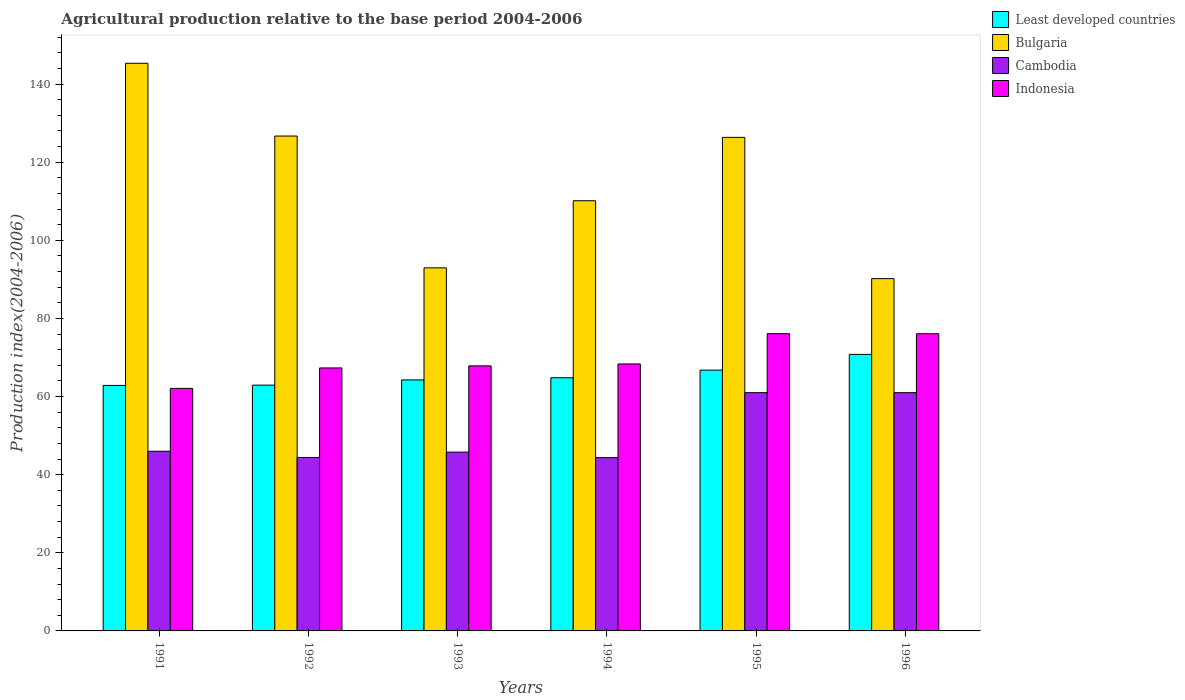How many groups of bars are there?
Provide a short and direct response. 6. Are the number of bars per tick equal to the number of legend labels?
Provide a short and direct response. Yes. Are the number of bars on each tick of the X-axis equal?
Your answer should be compact. Yes. How many bars are there on the 1st tick from the right?
Offer a terse response. 4. What is the label of the 6th group of bars from the left?
Your answer should be compact. 1996. In how many cases, is the number of bars for a given year not equal to the number of legend labels?
Ensure brevity in your answer.  0. What is the agricultural production index in Cambodia in 1995?
Your response must be concise. 60.99. Across all years, what is the maximum agricultural production index in Least developed countries?
Provide a succinct answer. 70.79. Across all years, what is the minimum agricultural production index in Least developed countries?
Your answer should be compact. 62.84. What is the total agricultural production index in Least developed countries in the graph?
Make the answer very short. 392.36. What is the difference between the agricultural production index in Cambodia in 1991 and that in 1993?
Provide a succinct answer. 0.23. What is the difference between the agricultural production index in Least developed countries in 1992 and the agricultural production index in Bulgaria in 1991?
Keep it short and to the point. -82.39. What is the average agricultural production index in Cambodia per year?
Provide a short and direct response. 50.42. In the year 1991, what is the difference between the agricultural production index in Cambodia and agricultural production index in Indonesia?
Ensure brevity in your answer.  -16.08. What is the ratio of the agricultural production index in Bulgaria in 1993 to that in 1996?
Provide a short and direct response. 1.03. Is the difference between the agricultural production index in Cambodia in 1992 and 1993 greater than the difference between the agricultural production index in Indonesia in 1992 and 1993?
Your answer should be very brief. No. What is the difference between the highest and the second highest agricultural production index in Indonesia?
Offer a very short reply. 0.02. What is the difference between the highest and the lowest agricultural production index in Cambodia?
Give a very brief answer. 16.63. Is the sum of the agricultural production index in Cambodia in 1993 and 1994 greater than the maximum agricultural production index in Bulgaria across all years?
Give a very brief answer. No. What does the 2nd bar from the left in 1996 represents?
Provide a succinct answer. Bulgaria. What does the 2nd bar from the right in 1996 represents?
Provide a short and direct response. Cambodia. How many bars are there?
Your response must be concise. 24. How many years are there in the graph?
Provide a short and direct response. 6. What is the difference between two consecutive major ticks on the Y-axis?
Make the answer very short. 20. Are the values on the major ticks of Y-axis written in scientific E-notation?
Your response must be concise. No. Does the graph contain any zero values?
Offer a very short reply. No. Does the graph contain grids?
Make the answer very short. No. How many legend labels are there?
Your response must be concise. 4. What is the title of the graph?
Keep it short and to the point. Agricultural production relative to the base period 2004-2006. What is the label or title of the Y-axis?
Provide a short and direct response. Production index(2004-2006). What is the Production index(2004-2006) of Least developed countries in 1991?
Offer a very short reply. 62.84. What is the Production index(2004-2006) in Bulgaria in 1991?
Provide a succinct answer. 145.31. What is the Production index(2004-2006) in Indonesia in 1991?
Offer a very short reply. 62.08. What is the Production index(2004-2006) in Least developed countries in 1992?
Your answer should be compact. 62.92. What is the Production index(2004-2006) in Bulgaria in 1992?
Provide a succinct answer. 126.68. What is the Production index(2004-2006) in Cambodia in 1992?
Your response must be concise. 44.4. What is the Production index(2004-2006) of Indonesia in 1992?
Ensure brevity in your answer.  67.32. What is the Production index(2004-2006) of Least developed countries in 1993?
Offer a very short reply. 64.25. What is the Production index(2004-2006) of Bulgaria in 1993?
Provide a short and direct response. 92.94. What is the Production index(2004-2006) in Cambodia in 1993?
Offer a terse response. 45.77. What is the Production index(2004-2006) of Indonesia in 1993?
Ensure brevity in your answer.  67.85. What is the Production index(2004-2006) of Least developed countries in 1994?
Your answer should be very brief. 64.8. What is the Production index(2004-2006) in Bulgaria in 1994?
Your answer should be compact. 110.12. What is the Production index(2004-2006) of Cambodia in 1994?
Ensure brevity in your answer.  44.36. What is the Production index(2004-2006) in Indonesia in 1994?
Keep it short and to the point. 68.34. What is the Production index(2004-2006) of Least developed countries in 1995?
Provide a short and direct response. 66.75. What is the Production index(2004-2006) in Bulgaria in 1995?
Make the answer very short. 126.34. What is the Production index(2004-2006) in Cambodia in 1995?
Your answer should be compact. 60.99. What is the Production index(2004-2006) of Indonesia in 1995?
Offer a terse response. 76.09. What is the Production index(2004-2006) in Least developed countries in 1996?
Keep it short and to the point. 70.79. What is the Production index(2004-2006) of Bulgaria in 1996?
Offer a very short reply. 90.18. What is the Production index(2004-2006) in Cambodia in 1996?
Your answer should be very brief. 60.99. What is the Production index(2004-2006) in Indonesia in 1996?
Make the answer very short. 76.07. Across all years, what is the maximum Production index(2004-2006) of Least developed countries?
Provide a short and direct response. 70.79. Across all years, what is the maximum Production index(2004-2006) in Bulgaria?
Your answer should be compact. 145.31. Across all years, what is the maximum Production index(2004-2006) in Cambodia?
Make the answer very short. 60.99. Across all years, what is the maximum Production index(2004-2006) of Indonesia?
Give a very brief answer. 76.09. Across all years, what is the minimum Production index(2004-2006) of Least developed countries?
Keep it short and to the point. 62.84. Across all years, what is the minimum Production index(2004-2006) of Bulgaria?
Offer a very short reply. 90.18. Across all years, what is the minimum Production index(2004-2006) in Cambodia?
Your response must be concise. 44.36. Across all years, what is the minimum Production index(2004-2006) of Indonesia?
Provide a succinct answer. 62.08. What is the total Production index(2004-2006) of Least developed countries in the graph?
Offer a very short reply. 392.36. What is the total Production index(2004-2006) in Bulgaria in the graph?
Offer a very short reply. 691.57. What is the total Production index(2004-2006) in Cambodia in the graph?
Ensure brevity in your answer.  302.51. What is the total Production index(2004-2006) in Indonesia in the graph?
Ensure brevity in your answer.  417.75. What is the difference between the Production index(2004-2006) in Least developed countries in 1991 and that in 1992?
Offer a terse response. -0.07. What is the difference between the Production index(2004-2006) in Bulgaria in 1991 and that in 1992?
Offer a very short reply. 18.63. What is the difference between the Production index(2004-2006) of Indonesia in 1991 and that in 1992?
Your response must be concise. -5.24. What is the difference between the Production index(2004-2006) of Least developed countries in 1991 and that in 1993?
Ensure brevity in your answer.  -1.41. What is the difference between the Production index(2004-2006) of Bulgaria in 1991 and that in 1993?
Your answer should be compact. 52.37. What is the difference between the Production index(2004-2006) in Cambodia in 1991 and that in 1993?
Provide a short and direct response. 0.23. What is the difference between the Production index(2004-2006) in Indonesia in 1991 and that in 1993?
Your answer should be very brief. -5.77. What is the difference between the Production index(2004-2006) of Least developed countries in 1991 and that in 1994?
Keep it short and to the point. -1.96. What is the difference between the Production index(2004-2006) in Bulgaria in 1991 and that in 1994?
Your answer should be very brief. 35.19. What is the difference between the Production index(2004-2006) in Cambodia in 1991 and that in 1994?
Give a very brief answer. 1.64. What is the difference between the Production index(2004-2006) in Indonesia in 1991 and that in 1994?
Give a very brief answer. -6.26. What is the difference between the Production index(2004-2006) of Least developed countries in 1991 and that in 1995?
Make the answer very short. -3.91. What is the difference between the Production index(2004-2006) of Bulgaria in 1991 and that in 1995?
Your answer should be very brief. 18.97. What is the difference between the Production index(2004-2006) of Cambodia in 1991 and that in 1995?
Your response must be concise. -14.99. What is the difference between the Production index(2004-2006) in Indonesia in 1991 and that in 1995?
Keep it short and to the point. -14.01. What is the difference between the Production index(2004-2006) in Least developed countries in 1991 and that in 1996?
Ensure brevity in your answer.  -7.94. What is the difference between the Production index(2004-2006) of Bulgaria in 1991 and that in 1996?
Your answer should be compact. 55.13. What is the difference between the Production index(2004-2006) of Cambodia in 1991 and that in 1996?
Offer a terse response. -14.99. What is the difference between the Production index(2004-2006) in Indonesia in 1991 and that in 1996?
Provide a short and direct response. -13.99. What is the difference between the Production index(2004-2006) in Least developed countries in 1992 and that in 1993?
Offer a very short reply. -1.34. What is the difference between the Production index(2004-2006) in Bulgaria in 1992 and that in 1993?
Your response must be concise. 33.74. What is the difference between the Production index(2004-2006) in Cambodia in 1992 and that in 1993?
Give a very brief answer. -1.37. What is the difference between the Production index(2004-2006) of Indonesia in 1992 and that in 1993?
Ensure brevity in your answer.  -0.53. What is the difference between the Production index(2004-2006) of Least developed countries in 1992 and that in 1994?
Your response must be concise. -1.89. What is the difference between the Production index(2004-2006) in Bulgaria in 1992 and that in 1994?
Your response must be concise. 16.56. What is the difference between the Production index(2004-2006) of Cambodia in 1992 and that in 1994?
Provide a succinct answer. 0.04. What is the difference between the Production index(2004-2006) of Indonesia in 1992 and that in 1994?
Provide a succinct answer. -1.02. What is the difference between the Production index(2004-2006) of Least developed countries in 1992 and that in 1995?
Give a very brief answer. -3.84. What is the difference between the Production index(2004-2006) in Bulgaria in 1992 and that in 1995?
Give a very brief answer. 0.34. What is the difference between the Production index(2004-2006) in Cambodia in 1992 and that in 1995?
Give a very brief answer. -16.59. What is the difference between the Production index(2004-2006) in Indonesia in 1992 and that in 1995?
Make the answer very short. -8.77. What is the difference between the Production index(2004-2006) in Least developed countries in 1992 and that in 1996?
Make the answer very short. -7.87. What is the difference between the Production index(2004-2006) in Bulgaria in 1992 and that in 1996?
Your answer should be very brief. 36.5. What is the difference between the Production index(2004-2006) of Cambodia in 1992 and that in 1996?
Your answer should be very brief. -16.59. What is the difference between the Production index(2004-2006) of Indonesia in 1992 and that in 1996?
Your answer should be compact. -8.75. What is the difference between the Production index(2004-2006) of Least developed countries in 1993 and that in 1994?
Offer a terse response. -0.55. What is the difference between the Production index(2004-2006) of Bulgaria in 1993 and that in 1994?
Ensure brevity in your answer.  -17.18. What is the difference between the Production index(2004-2006) of Cambodia in 1993 and that in 1994?
Provide a short and direct response. 1.41. What is the difference between the Production index(2004-2006) of Indonesia in 1993 and that in 1994?
Provide a succinct answer. -0.49. What is the difference between the Production index(2004-2006) of Least developed countries in 1993 and that in 1995?
Offer a very short reply. -2.5. What is the difference between the Production index(2004-2006) of Bulgaria in 1993 and that in 1995?
Make the answer very short. -33.4. What is the difference between the Production index(2004-2006) in Cambodia in 1993 and that in 1995?
Ensure brevity in your answer.  -15.22. What is the difference between the Production index(2004-2006) of Indonesia in 1993 and that in 1995?
Your response must be concise. -8.24. What is the difference between the Production index(2004-2006) in Least developed countries in 1993 and that in 1996?
Keep it short and to the point. -6.53. What is the difference between the Production index(2004-2006) of Bulgaria in 1993 and that in 1996?
Offer a terse response. 2.76. What is the difference between the Production index(2004-2006) of Cambodia in 1993 and that in 1996?
Give a very brief answer. -15.22. What is the difference between the Production index(2004-2006) of Indonesia in 1993 and that in 1996?
Ensure brevity in your answer.  -8.22. What is the difference between the Production index(2004-2006) in Least developed countries in 1994 and that in 1995?
Keep it short and to the point. -1.95. What is the difference between the Production index(2004-2006) in Bulgaria in 1994 and that in 1995?
Your answer should be very brief. -16.22. What is the difference between the Production index(2004-2006) of Cambodia in 1994 and that in 1995?
Ensure brevity in your answer.  -16.63. What is the difference between the Production index(2004-2006) in Indonesia in 1994 and that in 1995?
Offer a very short reply. -7.75. What is the difference between the Production index(2004-2006) of Least developed countries in 1994 and that in 1996?
Your response must be concise. -5.98. What is the difference between the Production index(2004-2006) in Bulgaria in 1994 and that in 1996?
Give a very brief answer. 19.94. What is the difference between the Production index(2004-2006) in Cambodia in 1994 and that in 1996?
Your answer should be compact. -16.63. What is the difference between the Production index(2004-2006) of Indonesia in 1994 and that in 1996?
Provide a succinct answer. -7.73. What is the difference between the Production index(2004-2006) in Least developed countries in 1995 and that in 1996?
Your answer should be very brief. -4.03. What is the difference between the Production index(2004-2006) of Bulgaria in 1995 and that in 1996?
Give a very brief answer. 36.16. What is the difference between the Production index(2004-2006) in Indonesia in 1995 and that in 1996?
Your response must be concise. 0.02. What is the difference between the Production index(2004-2006) in Least developed countries in 1991 and the Production index(2004-2006) in Bulgaria in 1992?
Make the answer very short. -63.84. What is the difference between the Production index(2004-2006) of Least developed countries in 1991 and the Production index(2004-2006) of Cambodia in 1992?
Ensure brevity in your answer.  18.44. What is the difference between the Production index(2004-2006) of Least developed countries in 1991 and the Production index(2004-2006) of Indonesia in 1992?
Provide a short and direct response. -4.48. What is the difference between the Production index(2004-2006) in Bulgaria in 1991 and the Production index(2004-2006) in Cambodia in 1992?
Your answer should be compact. 100.91. What is the difference between the Production index(2004-2006) in Bulgaria in 1991 and the Production index(2004-2006) in Indonesia in 1992?
Your response must be concise. 77.99. What is the difference between the Production index(2004-2006) in Cambodia in 1991 and the Production index(2004-2006) in Indonesia in 1992?
Ensure brevity in your answer.  -21.32. What is the difference between the Production index(2004-2006) of Least developed countries in 1991 and the Production index(2004-2006) of Bulgaria in 1993?
Your response must be concise. -30.1. What is the difference between the Production index(2004-2006) in Least developed countries in 1991 and the Production index(2004-2006) in Cambodia in 1993?
Ensure brevity in your answer.  17.07. What is the difference between the Production index(2004-2006) of Least developed countries in 1991 and the Production index(2004-2006) of Indonesia in 1993?
Your answer should be very brief. -5.01. What is the difference between the Production index(2004-2006) of Bulgaria in 1991 and the Production index(2004-2006) of Cambodia in 1993?
Your response must be concise. 99.54. What is the difference between the Production index(2004-2006) of Bulgaria in 1991 and the Production index(2004-2006) of Indonesia in 1993?
Provide a succinct answer. 77.46. What is the difference between the Production index(2004-2006) in Cambodia in 1991 and the Production index(2004-2006) in Indonesia in 1993?
Your answer should be compact. -21.85. What is the difference between the Production index(2004-2006) of Least developed countries in 1991 and the Production index(2004-2006) of Bulgaria in 1994?
Your response must be concise. -47.28. What is the difference between the Production index(2004-2006) in Least developed countries in 1991 and the Production index(2004-2006) in Cambodia in 1994?
Make the answer very short. 18.48. What is the difference between the Production index(2004-2006) of Least developed countries in 1991 and the Production index(2004-2006) of Indonesia in 1994?
Keep it short and to the point. -5.5. What is the difference between the Production index(2004-2006) in Bulgaria in 1991 and the Production index(2004-2006) in Cambodia in 1994?
Offer a very short reply. 100.95. What is the difference between the Production index(2004-2006) in Bulgaria in 1991 and the Production index(2004-2006) in Indonesia in 1994?
Keep it short and to the point. 76.97. What is the difference between the Production index(2004-2006) in Cambodia in 1991 and the Production index(2004-2006) in Indonesia in 1994?
Provide a succinct answer. -22.34. What is the difference between the Production index(2004-2006) in Least developed countries in 1991 and the Production index(2004-2006) in Bulgaria in 1995?
Your answer should be compact. -63.5. What is the difference between the Production index(2004-2006) of Least developed countries in 1991 and the Production index(2004-2006) of Cambodia in 1995?
Give a very brief answer. 1.85. What is the difference between the Production index(2004-2006) of Least developed countries in 1991 and the Production index(2004-2006) of Indonesia in 1995?
Your answer should be very brief. -13.25. What is the difference between the Production index(2004-2006) of Bulgaria in 1991 and the Production index(2004-2006) of Cambodia in 1995?
Your answer should be very brief. 84.32. What is the difference between the Production index(2004-2006) in Bulgaria in 1991 and the Production index(2004-2006) in Indonesia in 1995?
Your answer should be very brief. 69.22. What is the difference between the Production index(2004-2006) of Cambodia in 1991 and the Production index(2004-2006) of Indonesia in 1995?
Offer a terse response. -30.09. What is the difference between the Production index(2004-2006) of Least developed countries in 1991 and the Production index(2004-2006) of Bulgaria in 1996?
Your response must be concise. -27.34. What is the difference between the Production index(2004-2006) in Least developed countries in 1991 and the Production index(2004-2006) in Cambodia in 1996?
Provide a succinct answer. 1.85. What is the difference between the Production index(2004-2006) of Least developed countries in 1991 and the Production index(2004-2006) of Indonesia in 1996?
Make the answer very short. -13.23. What is the difference between the Production index(2004-2006) of Bulgaria in 1991 and the Production index(2004-2006) of Cambodia in 1996?
Provide a succinct answer. 84.32. What is the difference between the Production index(2004-2006) in Bulgaria in 1991 and the Production index(2004-2006) in Indonesia in 1996?
Offer a terse response. 69.24. What is the difference between the Production index(2004-2006) of Cambodia in 1991 and the Production index(2004-2006) of Indonesia in 1996?
Provide a succinct answer. -30.07. What is the difference between the Production index(2004-2006) of Least developed countries in 1992 and the Production index(2004-2006) of Bulgaria in 1993?
Provide a short and direct response. -30.02. What is the difference between the Production index(2004-2006) in Least developed countries in 1992 and the Production index(2004-2006) in Cambodia in 1993?
Give a very brief answer. 17.15. What is the difference between the Production index(2004-2006) of Least developed countries in 1992 and the Production index(2004-2006) of Indonesia in 1993?
Your answer should be compact. -4.93. What is the difference between the Production index(2004-2006) of Bulgaria in 1992 and the Production index(2004-2006) of Cambodia in 1993?
Make the answer very short. 80.91. What is the difference between the Production index(2004-2006) of Bulgaria in 1992 and the Production index(2004-2006) of Indonesia in 1993?
Provide a succinct answer. 58.83. What is the difference between the Production index(2004-2006) in Cambodia in 1992 and the Production index(2004-2006) in Indonesia in 1993?
Your answer should be compact. -23.45. What is the difference between the Production index(2004-2006) of Least developed countries in 1992 and the Production index(2004-2006) of Bulgaria in 1994?
Give a very brief answer. -47.2. What is the difference between the Production index(2004-2006) of Least developed countries in 1992 and the Production index(2004-2006) of Cambodia in 1994?
Your answer should be very brief. 18.56. What is the difference between the Production index(2004-2006) of Least developed countries in 1992 and the Production index(2004-2006) of Indonesia in 1994?
Keep it short and to the point. -5.42. What is the difference between the Production index(2004-2006) in Bulgaria in 1992 and the Production index(2004-2006) in Cambodia in 1994?
Make the answer very short. 82.32. What is the difference between the Production index(2004-2006) of Bulgaria in 1992 and the Production index(2004-2006) of Indonesia in 1994?
Your response must be concise. 58.34. What is the difference between the Production index(2004-2006) in Cambodia in 1992 and the Production index(2004-2006) in Indonesia in 1994?
Your answer should be very brief. -23.94. What is the difference between the Production index(2004-2006) of Least developed countries in 1992 and the Production index(2004-2006) of Bulgaria in 1995?
Provide a short and direct response. -63.42. What is the difference between the Production index(2004-2006) of Least developed countries in 1992 and the Production index(2004-2006) of Cambodia in 1995?
Provide a succinct answer. 1.93. What is the difference between the Production index(2004-2006) of Least developed countries in 1992 and the Production index(2004-2006) of Indonesia in 1995?
Offer a terse response. -13.17. What is the difference between the Production index(2004-2006) of Bulgaria in 1992 and the Production index(2004-2006) of Cambodia in 1995?
Provide a short and direct response. 65.69. What is the difference between the Production index(2004-2006) in Bulgaria in 1992 and the Production index(2004-2006) in Indonesia in 1995?
Your response must be concise. 50.59. What is the difference between the Production index(2004-2006) of Cambodia in 1992 and the Production index(2004-2006) of Indonesia in 1995?
Keep it short and to the point. -31.69. What is the difference between the Production index(2004-2006) of Least developed countries in 1992 and the Production index(2004-2006) of Bulgaria in 1996?
Offer a very short reply. -27.26. What is the difference between the Production index(2004-2006) of Least developed countries in 1992 and the Production index(2004-2006) of Cambodia in 1996?
Your answer should be compact. 1.93. What is the difference between the Production index(2004-2006) in Least developed countries in 1992 and the Production index(2004-2006) in Indonesia in 1996?
Provide a succinct answer. -13.15. What is the difference between the Production index(2004-2006) of Bulgaria in 1992 and the Production index(2004-2006) of Cambodia in 1996?
Offer a very short reply. 65.69. What is the difference between the Production index(2004-2006) of Bulgaria in 1992 and the Production index(2004-2006) of Indonesia in 1996?
Your answer should be very brief. 50.61. What is the difference between the Production index(2004-2006) in Cambodia in 1992 and the Production index(2004-2006) in Indonesia in 1996?
Make the answer very short. -31.67. What is the difference between the Production index(2004-2006) in Least developed countries in 1993 and the Production index(2004-2006) in Bulgaria in 1994?
Provide a succinct answer. -45.87. What is the difference between the Production index(2004-2006) of Least developed countries in 1993 and the Production index(2004-2006) of Cambodia in 1994?
Your answer should be very brief. 19.89. What is the difference between the Production index(2004-2006) of Least developed countries in 1993 and the Production index(2004-2006) of Indonesia in 1994?
Keep it short and to the point. -4.09. What is the difference between the Production index(2004-2006) of Bulgaria in 1993 and the Production index(2004-2006) of Cambodia in 1994?
Offer a very short reply. 48.58. What is the difference between the Production index(2004-2006) in Bulgaria in 1993 and the Production index(2004-2006) in Indonesia in 1994?
Provide a succinct answer. 24.6. What is the difference between the Production index(2004-2006) in Cambodia in 1993 and the Production index(2004-2006) in Indonesia in 1994?
Your response must be concise. -22.57. What is the difference between the Production index(2004-2006) in Least developed countries in 1993 and the Production index(2004-2006) in Bulgaria in 1995?
Make the answer very short. -62.09. What is the difference between the Production index(2004-2006) of Least developed countries in 1993 and the Production index(2004-2006) of Cambodia in 1995?
Provide a short and direct response. 3.26. What is the difference between the Production index(2004-2006) of Least developed countries in 1993 and the Production index(2004-2006) of Indonesia in 1995?
Provide a short and direct response. -11.84. What is the difference between the Production index(2004-2006) in Bulgaria in 1993 and the Production index(2004-2006) in Cambodia in 1995?
Offer a very short reply. 31.95. What is the difference between the Production index(2004-2006) in Bulgaria in 1993 and the Production index(2004-2006) in Indonesia in 1995?
Give a very brief answer. 16.85. What is the difference between the Production index(2004-2006) in Cambodia in 1993 and the Production index(2004-2006) in Indonesia in 1995?
Provide a succinct answer. -30.32. What is the difference between the Production index(2004-2006) in Least developed countries in 1993 and the Production index(2004-2006) in Bulgaria in 1996?
Make the answer very short. -25.93. What is the difference between the Production index(2004-2006) of Least developed countries in 1993 and the Production index(2004-2006) of Cambodia in 1996?
Your response must be concise. 3.26. What is the difference between the Production index(2004-2006) of Least developed countries in 1993 and the Production index(2004-2006) of Indonesia in 1996?
Offer a very short reply. -11.82. What is the difference between the Production index(2004-2006) in Bulgaria in 1993 and the Production index(2004-2006) in Cambodia in 1996?
Ensure brevity in your answer.  31.95. What is the difference between the Production index(2004-2006) of Bulgaria in 1993 and the Production index(2004-2006) of Indonesia in 1996?
Offer a very short reply. 16.87. What is the difference between the Production index(2004-2006) of Cambodia in 1993 and the Production index(2004-2006) of Indonesia in 1996?
Make the answer very short. -30.3. What is the difference between the Production index(2004-2006) of Least developed countries in 1994 and the Production index(2004-2006) of Bulgaria in 1995?
Keep it short and to the point. -61.54. What is the difference between the Production index(2004-2006) in Least developed countries in 1994 and the Production index(2004-2006) in Cambodia in 1995?
Ensure brevity in your answer.  3.81. What is the difference between the Production index(2004-2006) in Least developed countries in 1994 and the Production index(2004-2006) in Indonesia in 1995?
Keep it short and to the point. -11.29. What is the difference between the Production index(2004-2006) in Bulgaria in 1994 and the Production index(2004-2006) in Cambodia in 1995?
Give a very brief answer. 49.13. What is the difference between the Production index(2004-2006) in Bulgaria in 1994 and the Production index(2004-2006) in Indonesia in 1995?
Your response must be concise. 34.03. What is the difference between the Production index(2004-2006) in Cambodia in 1994 and the Production index(2004-2006) in Indonesia in 1995?
Your answer should be very brief. -31.73. What is the difference between the Production index(2004-2006) in Least developed countries in 1994 and the Production index(2004-2006) in Bulgaria in 1996?
Offer a terse response. -25.38. What is the difference between the Production index(2004-2006) of Least developed countries in 1994 and the Production index(2004-2006) of Cambodia in 1996?
Your answer should be very brief. 3.81. What is the difference between the Production index(2004-2006) of Least developed countries in 1994 and the Production index(2004-2006) of Indonesia in 1996?
Your answer should be compact. -11.27. What is the difference between the Production index(2004-2006) of Bulgaria in 1994 and the Production index(2004-2006) of Cambodia in 1996?
Ensure brevity in your answer.  49.13. What is the difference between the Production index(2004-2006) of Bulgaria in 1994 and the Production index(2004-2006) of Indonesia in 1996?
Ensure brevity in your answer.  34.05. What is the difference between the Production index(2004-2006) in Cambodia in 1994 and the Production index(2004-2006) in Indonesia in 1996?
Make the answer very short. -31.71. What is the difference between the Production index(2004-2006) in Least developed countries in 1995 and the Production index(2004-2006) in Bulgaria in 1996?
Your answer should be compact. -23.43. What is the difference between the Production index(2004-2006) of Least developed countries in 1995 and the Production index(2004-2006) of Cambodia in 1996?
Keep it short and to the point. 5.76. What is the difference between the Production index(2004-2006) in Least developed countries in 1995 and the Production index(2004-2006) in Indonesia in 1996?
Keep it short and to the point. -9.32. What is the difference between the Production index(2004-2006) in Bulgaria in 1995 and the Production index(2004-2006) in Cambodia in 1996?
Give a very brief answer. 65.35. What is the difference between the Production index(2004-2006) in Bulgaria in 1995 and the Production index(2004-2006) in Indonesia in 1996?
Ensure brevity in your answer.  50.27. What is the difference between the Production index(2004-2006) in Cambodia in 1995 and the Production index(2004-2006) in Indonesia in 1996?
Keep it short and to the point. -15.08. What is the average Production index(2004-2006) in Least developed countries per year?
Offer a terse response. 65.39. What is the average Production index(2004-2006) in Bulgaria per year?
Offer a terse response. 115.26. What is the average Production index(2004-2006) of Cambodia per year?
Give a very brief answer. 50.42. What is the average Production index(2004-2006) in Indonesia per year?
Offer a terse response. 69.62. In the year 1991, what is the difference between the Production index(2004-2006) of Least developed countries and Production index(2004-2006) of Bulgaria?
Make the answer very short. -82.47. In the year 1991, what is the difference between the Production index(2004-2006) of Least developed countries and Production index(2004-2006) of Cambodia?
Keep it short and to the point. 16.84. In the year 1991, what is the difference between the Production index(2004-2006) in Least developed countries and Production index(2004-2006) in Indonesia?
Keep it short and to the point. 0.76. In the year 1991, what is the difference between the Production index(2004-2006) in Bulgaria and Production index(2004-2006) in Cambodia?
Provide a short and direct response. 99.31. In the year 1991, what is the difference between the Production index(2004-2006) of Bulgaria and Production index(2004-2006) of Indonesia?
Your answer should be very brief. 83.23. In the year 1991, what is the difference between the Production index(2004-2006) of Cambodia and Production index(2004-2006) of Indonesia?
Provide a succinct answer. -16.08. In the year 1992, what is the difference between the Production index(2004-2006) of Least developed countries and Production index(2004-2006) of Bulgaria?
Provide a short and direct response. -63.76. In the year 1992, what is the difference between the Production index(2004-2006) of Least developed countries and Production index(2004-2006) of Cambodia?
Your response must be concise. 18.52. In the year 1992, what is the difference between the Production index(2004-2006) in Least developed countries and Production index(2004-2006) in Indonesia?
Your response must be concise. -4.4. In the year 1992, what is the difference between the Production index(2004-2006) in Bulgaria and Production index(2004-2006) in Cambodia?
Offer a terse response. 82.28. In the year 1992, what is the difference between the Production index(2004-2006) of Bulgaria and Production index(2004-2006) of Indonesia?
Keep it short and to the point. 59.36. In the year 1992, what is the difference between the Production index(2004-2006) of Cambodia and Production index(2004-2006) of Indonesia?
Provide a succinct answer. -22.92. In the year 1993, what is the difference between the Production index(2004-2006) in Least developed countries and Production index(2004-2006) in Bulgaria?
Offer a very short reply. -28.69. In the year 1993, what is the difference between the Production index(2004-2006) of Least developed countries and Production index(2004-2006) of Cambodia?
Provide a short and direct response. 18.48. In the year 1993, what is the difference between the Production index(2004-2006) in Least developed countries and Production index(2004-2006) in Indonesia?
Your answer should be very brief. -3.6. In the year 1993, what is the difference between the Production index(2004-2006) of Bulgaria and Production index(2004-2006) of Cambodia?
Your answer should be very brief. 47.17. In the year 1993, what is the difference between the Production index(2004-2006) in Bulgaria and Production index(2004-2006) in Indonesia?
Your response must be concise. 25.09. In the year 1993, what is the difference between the Production index(2004-2006) of Cambodia and Production index(2004-2006) of Indonesia?
Your response must be concise. -22.08. In the year 1994, what is the difference between the Production index(2004-2006) of Least developed countries and Production index(2004-2006) of Bulgaria?
Ensure brevity in your answer.  -45.32. In the year 1994, what is the difference between the Production index(2004-2006) of Least developed countries and Production index(2004-2006) of Cambodia?
Offer a very short reply. 20.44. In the year 1994, what is the difference between the Production index(2004-2006) of Least developed countries and Production index(2004-2006) of Indonesia?
Your response must be concise. -3.54. In the year 1994, what is the difference between the Production index(2004-2006) of Bulgaria and Production index(2004-2006) of Cambodia?
Provide a short and direct response. 65.76. In the year 1994, what is the difference between the Production index(2004-2006) of Bulgaria and Production index(2004-2006) of Indonesia?
Make the answer very short. 41.78. In the year 1994, what is the difference between the Production index(2004-2006) of Cambodia and Production index(2004-2006) of Indonesia?
Your answer should be very brief. -23.98. In the year 1995, what is the difference between the Production index(2004-2006) of Least developed countries and Production index(2004-2006) of Bulgaria?
Your response must be concise. -59.59. In the year 1995, what is the difference between the Production index(2004-2006) in Least developed countries and Production index(2004-2006) in Cambodia?
Offer a very short reply. 5.76. In the year 1995, what is the difference between the Production index(2004-2006) in Least developed countries and Production index(2004-2006) in Indonesia?
Your answer should be compact. -9.34. In the year 1995, what is the difference between the Production index(2004-2006) in Bulgaria and Production index(2004-2006) in Cambodia?
Your answer should be very brief. 65.35. In the year 1995, what is the difference between the Production index(2004-2006) of Bulgaria and Production index(2004-2006) of Indonesia?
Make the answer very short. 50.25. In the year 1995, what is the difference between the Production index(2004-2006) in Cambodia and Production index(2004-2006) in Indonesia?
Give a very brief answer. -15.1. In the year 1996, what is the difference between the Production index(2004-2006) in Least developed countries and Production index(2004-2006) in Bulgaria?
Your response must be concise. -19.39. In the year 1996, what is the difference between the Production index(2004-2006) in Least developed countries and Production index(2004-2006) in Cambodia?
Your response must be concise. 9.8. In the year 1996, what is the difference between the Production index(2004-2006) of Least developed countries and Production index(2004-2006) of Indonesia?
Provide a short and direct response. -5.28. In the year 1996, what is the difference between the Production index(2004-2006) in Bulgaria and Production index(2004-2006) in Cambodia?
Your answer should be compact. 29.19. In the year 1996, what is the difference between the Production index(2004-2006) in Bulgaria and Production index(2004-2006) in Indonesia?
Offer a very short reply. 14.11. In the year 1996, what is the difference between the Production index(2004-2006) in Cambodia and Production index(2004-2006) in Indonesia?
Offer a terse response. -15.08. What is the ratio of the Production index(2004-2006) in Least developed countries in 1991 to that in 1992?
Offer a terse response. 1. What is the ratio of the Production index(2004-2006) of Bulgaria in 1991 to that in 1992?
Your answer should be very brief. 1.15. What is the ratio of the Production index(2004-2006) of Cambodia in 1991 to that in 1992?
Your answer should be compact. 1.04. What is the ratio of the Production index(2004-2006) of Indonesia in 1991 to that in 1992?
Keep it short and to the point. 0.92. What is the ratio of the Production index(2004-2006) in Least developed countries in 1991 to that in 1993?
Offer a terse response. 0.98. What is the ratio of the Production index(2004-2006) in Bulgaria in 1991 to that in 1993?
Provide a short and direct response. 1.56. What is the ratio of the Production index(2004-2006) of Cambodia in 1991 to that in 1993?
Your response must be concise. 1. What is the ratio of the Production index(2004-2006) in Indonesia in 1991 to that in 1993?
Make the answer very short. 0.92. What is the ratio of the Production index(2004-2006) of Least developed countries in 1991 to that in 1994?
Make the answer very short. 0.97. What is the ratio of the Production index(2004-2006) in Bulgaria in 1991 to that in 1994?
Your answer should be very brief. 1.32. What is the ratio of the Production index(2004-2006) in Indonesia in 1991 to that in 1994?
Your answer should be very brief. 0.91. What is the ratio of the Production index(2004-2006) of Least developed countries in 1991 to that in 1995?
Offer a very short reply. 0.94. What is the ratio of the Production index(2004-2006) of Bulgaria in 1991 to that in 1995?
Ensure brevity in your answer.  1.15. What is the ratio of the Production index(2004-2006) of Cambodia in 1991 to that in 1995?
Provide a short and direct response. 0.75. What is the ratio of the Production index(2004-2006) in Indonesia in 1991 to that in 1995?
Keep it short and to the point. 0.82. What is the ratio of the Production index(2004-2006) in Least developed countries in 1991 to that in 1996?
Your response must be concise. 0.89. What is the ratio of the Production index(2004-2006) in Bulgaria in 1991 to that in 1996?
Offer a very short reply. 1.61. What is the ratio of the Production index(2004-2006) of Cambodia in 1991 to that in 1996?
Ensure brevity in your answer.  0.75. What is the ratio of the Production index(2004-2006) in Indonesia in 1991 to that in 1996?
Ensure brevity in your answer.  0.82. What is the ratio of the Production index(2004-2006) of Least developed countries in 1992 to that in 1993?
Make the answer very short. 0.98. What is the ratio of the Production index(2004-2006) of Bulgaria in 1992 to that in 1993?
Your answer should be very brief. 1.36. What is the ratio of the Production index(2004-2006) in Cambodia in 1992 to that in 1993?
Offer a terse response. 0.97. What is the ratio of the Production index(2004-2006) in Indonesia in 1992 to that in 1993?
Your response must be concise. 0.99. What is the ratio of the Production index(2004-2006) of Least developed countries in 1992 to that in 1994?
Provide a short and direct response. 0.97. What is the ratio of the Production index(2004-2006) in Bulgaria in 1992 to that in 1994?
Keep it short and to the point. 1.15. What is the ratio of the Production index(2004-2006) in Indonesia in 1992 to that in 1994?
Your response must be concise. 0.99. What is the ratio of the Production index(2004-2006) in Least developed countries in 1992 to that in 1995?
Keep it short and to the point. 0.94. What is the ratio of the Production index(2004-2006) in Bulgaria in 1992 to that in 1995?
Your response must be concise. 1. What is the ratio of the Production index(2004-2006) in Cambodia in 1992 to that in 1995?
Your answer should be compact. 0.73. What is the ratio of the Production index(2004-2006) of Indonesia in 1992 to that in 1995?
Provide a short and direct response. 0.88. What is the ratio of the Production index(2004-2006) in Least developed countries in 1992 to that in 1996?
Ensure brevity in your answer.  0.89. What is the ratio of the Production index(2004-2006) of Bulgaria in 1992 to that in 1996?
Offer a very short reply. 1.4. What is the ratio of the Production index(2004-2006) of Cambodia in 1992 to that in 1996?
Provide a short and direct response. 0.73. What is the ratio of the Production index(2004-2006) of Indonesia in 1992 to that in 1996?
Provide a succinct answer. 0.89. What is the ratio of the Production index(2004-2006) of Bulgaria in 1993 to that in 1994?
Ensure brevity in your answer.  0.84. What is the ratio of the Production index(2004-2006) of Cambodia in 1993 to that in 1994?
Offer a very short reply. 1.03. What is the ratio of the Production index(2004-2006) of Least developed countries in 1993 to that in 1995?
Make the answer very short. 0.96. What is the ratio of the Production index(2004-2006) of Bulgaria in 1993 to that in 1995?
Ensure brevity in your answer.  0.74. What is the ratio of the Production index(2004-2006) in Cambodia in 1993 to that in 1995?
Ensure brevity in your answer.  0.75. What is the ratio of the Production index(2004-2006) of Indonesia in 1993 to that in 1995?
Ensure brevity in your answer.  0.89. What is the ratio of the Production index(2004-2006) of Least developed countries in 1993 to that in 1996?
Keep it short and to the point. 0.91. What is the ratio of the Production index(2004-2006) of Bulgaria in 1993 to that in 1996?
Provide a short and direct response. 1.03. What is the ratio of the Production index(2004-2006) in Cambodia in 1993 to that in 1996?
Provide a succinct answer. 0.75. What is the ratio of the Production index(2004-2006) of Indonesia in 1993 to that in 1996?
Make the answer very short. 0.89. What is the ratio of the Production index(2004-2006) of Least developed countries in 1994 to that in 1995?
Provide a succinct answer. 0.97. What is the ratio of the Production index(2004-2006) of Bulgaria in 1994 to that in 1995?
Ensure brevity in your answer.  0.87. What is the ratio of the Production index(2004-2006) of Cambodia in 1994 to that in 1995?
Your answer should be compact. 0.73. What is the ratio of the Production index(2004-2006) of Indonesia in 1994 to that in 1995?
Provide a succinct answer. 0.9. What is the ratio of the Production index(2004-2006) of Least developed countries in 1994 to that in 1996?
Your response must be concise. 0.92. What is the ratio of the Production index(2004-2006) of Bulgaria in 1994 to that in 1996?
Keep it short and to the point. 1.22. What is the ratio of the Production index(2004-2006) of Cambodia in 1994 to that in 1996?
Keep it short and to the point. 0.73. What is the ratio of the Production index(2004-2006) of Indonesia in 1994 to that in 1996?
Provide a short and direct response. 0.9. What is the ratio of the Production index(2004-2006) in Least developed countries in 1995 to that in 1996?
Offer a terse response. 0.94. What is the ratio of the Production index(2004-2006) in Bulgaria in 1995 to that in 1996?
Your answer should be compact. 1.4. What is the ratio of the Production index(2004-2006) in Cambodia in 1995 to that in 1996?
Give a very brief answer. 1. What is the ratio of the Production index(2004-2006) of Indonesia in 1995 to that in 1996?
Your answer should be very brief. 1. What is the difference between the highest and the second highest Production index(2004-2006) of Least developed countries?
Provide a succinct answer. 4.03. What is the difference between the highest and the second highest Production index(2004-2006) in Bulgaria?
Your answer should be compact. 18.63. What is the difference between the highest and the lowest Production index(2004-2006) in Least developed countries?
Offer a very short reply. 7.94. What is the difference between the highest and the lowest Production index(2004-2006) in Bulgaria?
Provide a succinct answer. 55.13. What is the difference between the highest and the lowest Production index(2004-2006) of Cambodia?
Make the answer very short. 16.63. What is the difference between the highest and the lowest Production index(2004-2006) of Indonesia?
Your response must be concise. 14.01. 